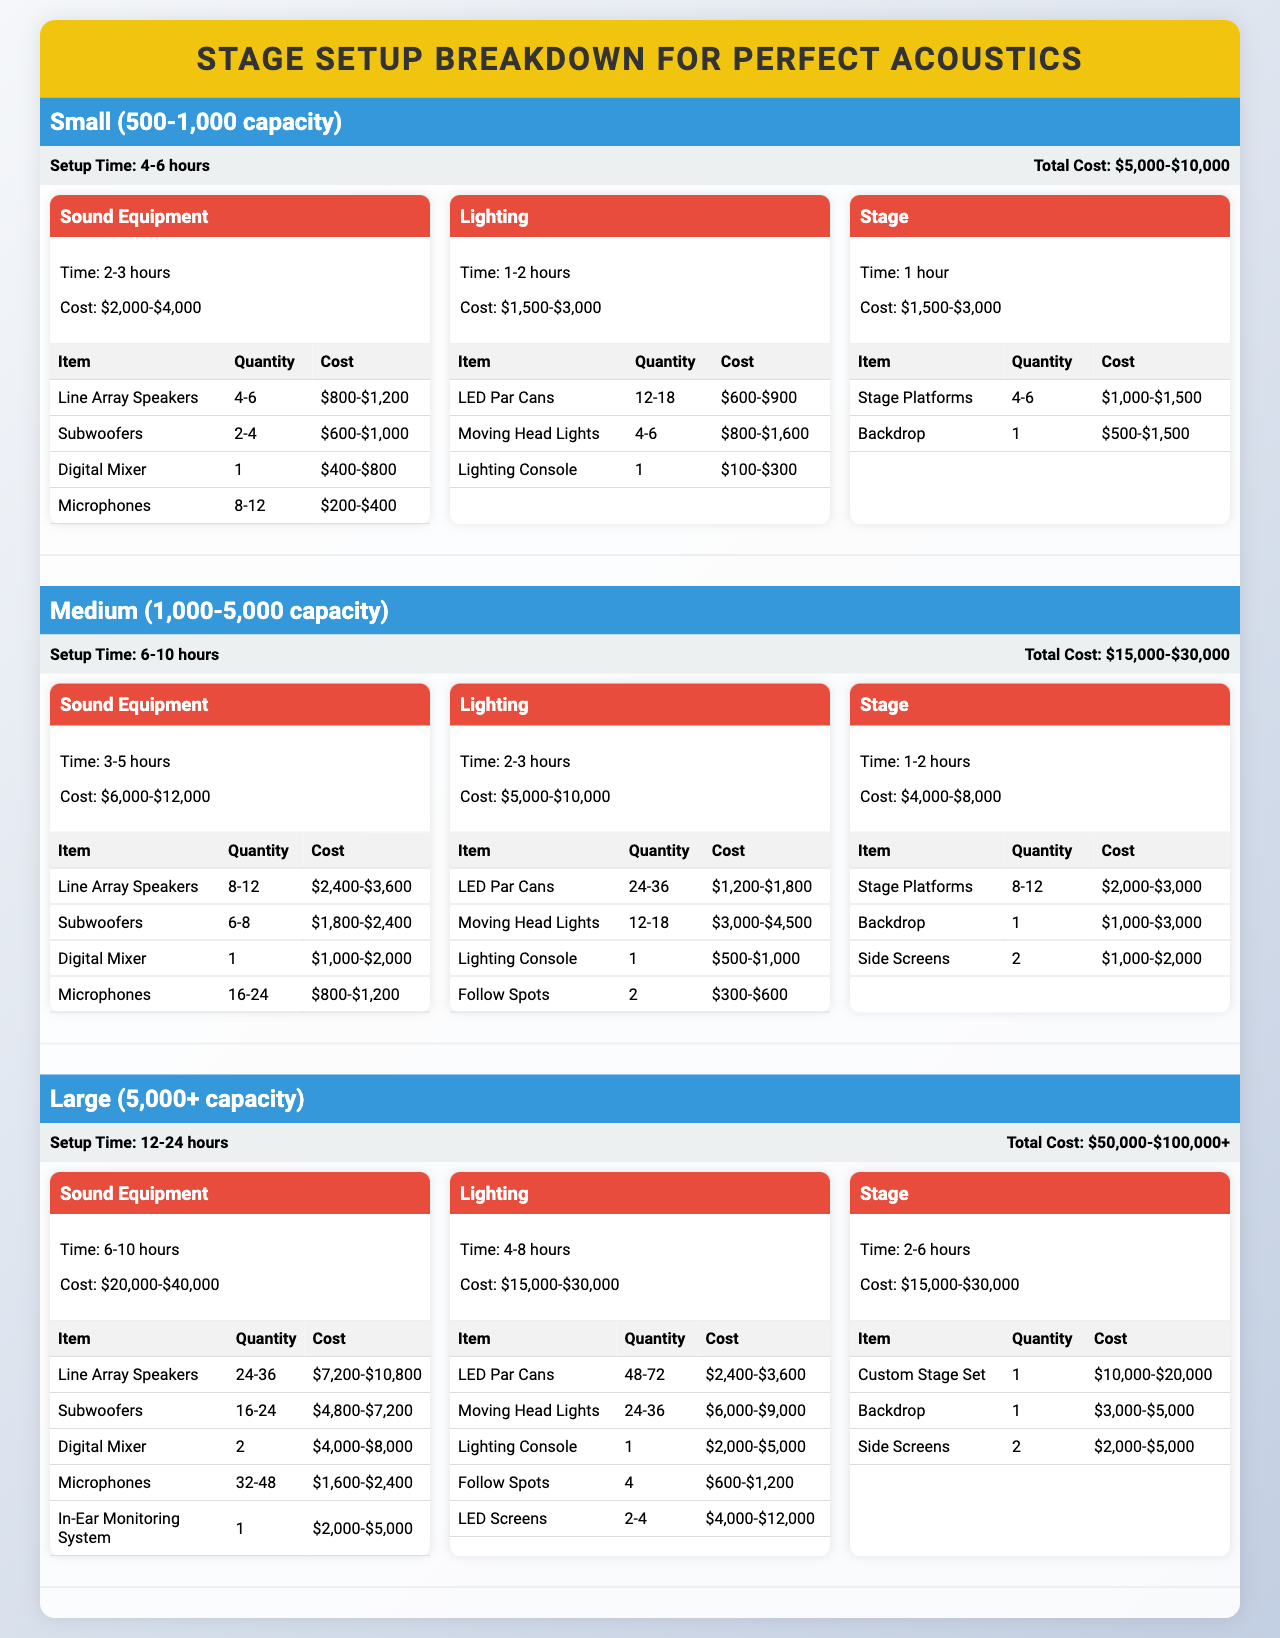What is the total cost range for a medium-sized venue? The table lists a total cost for medium-sized venues as "$15,000-$30,000."
Answer: $15,000-$30,000 How long does it take to set up sound equipment for a small venue? According to the breakdown for small venues, the setup time for sound equipment is "2-3 hours."
Answer: 2-3 hours Which category has the highest cost in large venues? For large venues, the sound equipment category has a total cost range of "$20,000-$40,000," which is higher than the other two categories.
Answer: Sound Equipment What is the average setup time for lighting in medium-sized venues? The setup time for lighting in medium venues is between 2-3 hours. To find the average, calculate (2 + 3)/2 = 2.5 hours.
Answer: 2.5 hours Is the cost for stage setup in small venues more than $3,000? The cost for stage setup in small venues is between "$1,500-$3,000," so it can reach up to $3,000 but not exceed it.
Answer: No How much does it cost to set up microphones for large venues? In the breakdown for large venues, the cost for 32-48 microphones is listed as "$1,600-$2,400."
Answer: $1,600-$2,400 What is the total setup time range for a large venue? The setup time for a large venue is listed as "12-24 hours," which indicates the duration required for complete setup.
Answer: 12-24 hours If you want to book moving head lights for a medium venue, what is the quantity needed at minimum? The table indicates the quantity required for moving head lights in medium venues is "12-18," so the minimum needed is 12.
Answer: 12 What is the overall trend in setup time from small to large venues? By reviewing the table, you can see that setup times increase from 4-6 hours for small venues to 12-24 hours for large venues. This indicates a positive trend in setup time with venue size.
Answer: Increased setup time For a medium venue, what is the total cost of sound equipment if we assume maximum expense? The maximum cost for sound equipment in medium venues can be calculated at $12,000. Based on the range of "$6,000-$12,000," so the maximum potential total is $12,000.
Answer: $12,000 